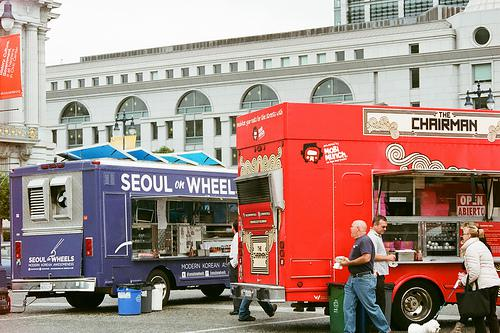Question: what vehicles are pictured?
Choices:
A. Tractor trailers.
B. Small cars.
C. Food trucks.
D. Dump trucks.
Answer with the letter. Answer: C Question: who is leaving the red truck?
Choices:
A. Redheaded man.
B. Brown haired man.
C. Blonde man.
D. Bald man.
Answer with the letter. Answer: D Question: why are the people in front of the truck?
Choices:
A. To buy food.
B. To get inside.
C. To talk to the driver.
D. To stop it from leaving.
Answer with the letter. Answer: A Question: what name is on the red truck?
Choices:
A. The Chairman.
B. The Beast.
C. The Monster.
D. The Red Rocket.
Answer with the letter. Answer: A 